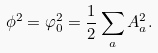<formula> <loc_0><loc_0><loc_500><loc_500>\phi ^ { 2 } = \varphi _ { 0 } ^ { 2 } = \frac { 1 } { 2 } \sum _ { a } A _ { a } ^ { 2 } .</formula> 